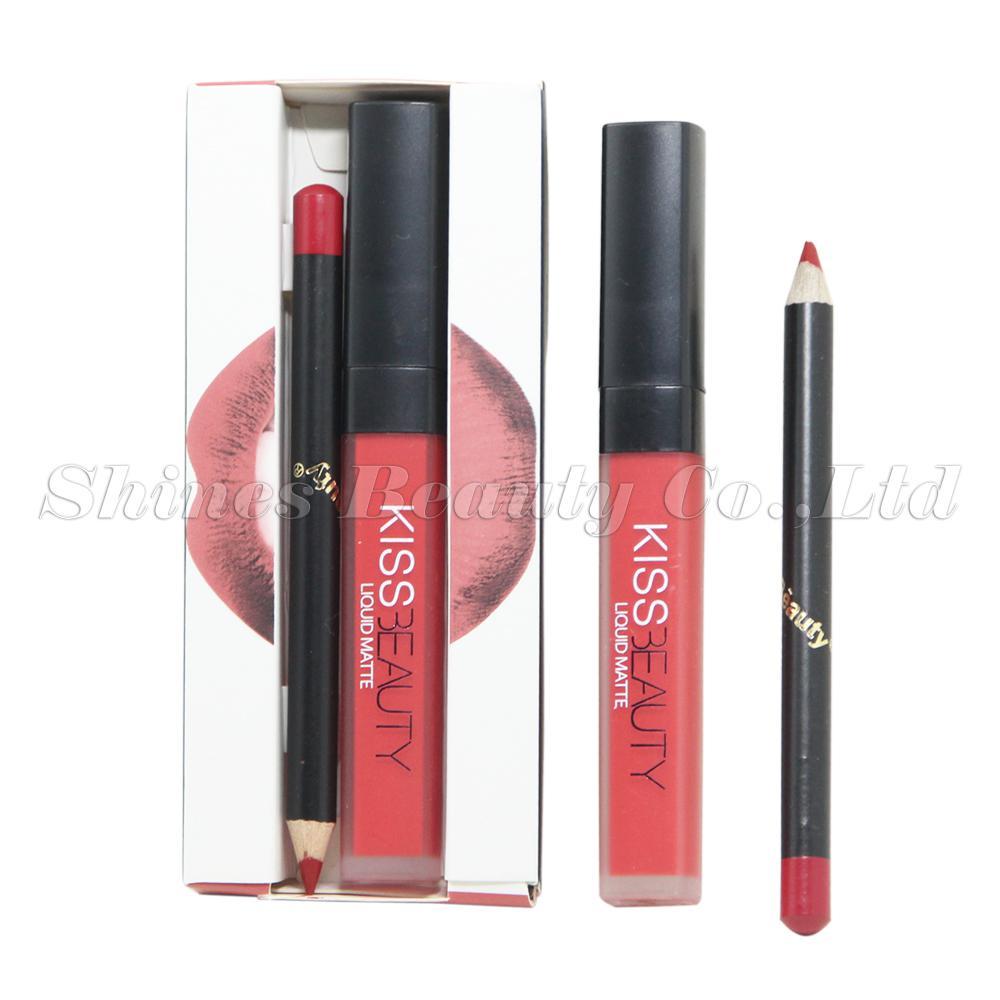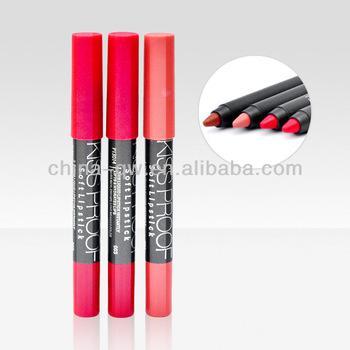The first image is the image on the left, the second image is the image on the right. Given the left and right images, does the statement "Each image in the pair shows the same number of uncapped lipsticks." hold true? Answer yes or no. No. 